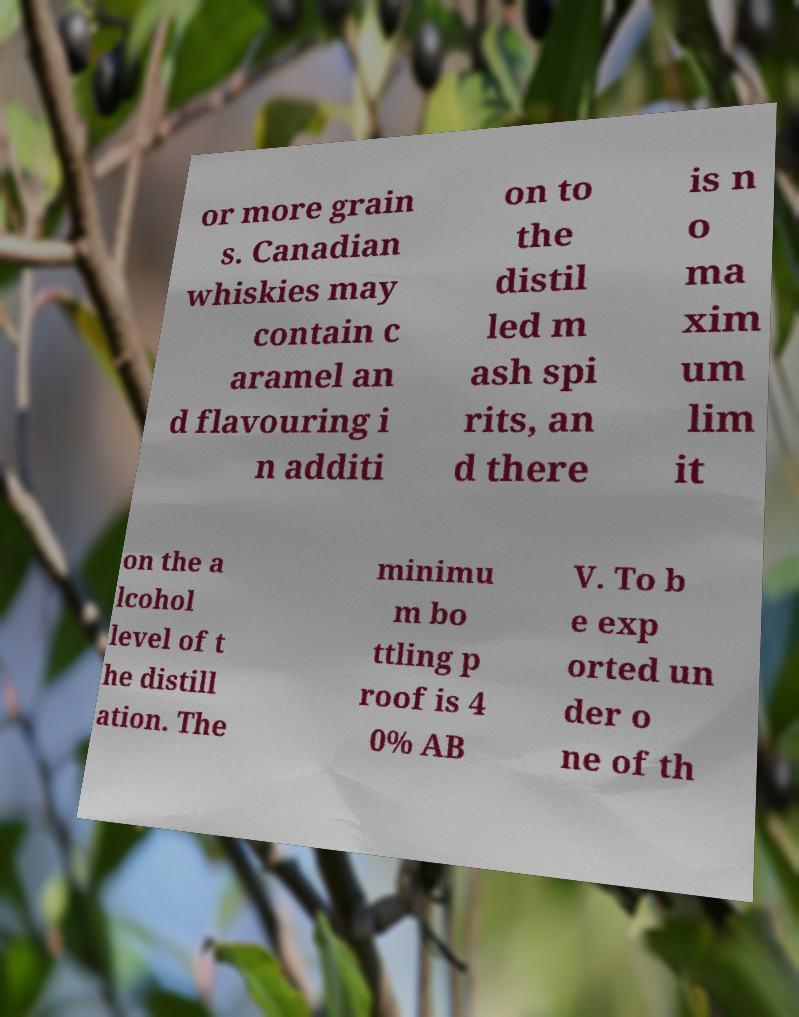There's text embedded in this image that I need extracted. Can you transcribe it verbatim? or more grain s. Canadian whiskies may contain c aramel an d flavouring i n additi on to the distil led m ash spi rits, an d there is n o ma xim um lim it on the a lcohol level of t he distill ation. The minimu m bo ttling p roof is 4 0% AB V. To b e exp orted un der o ne of th 